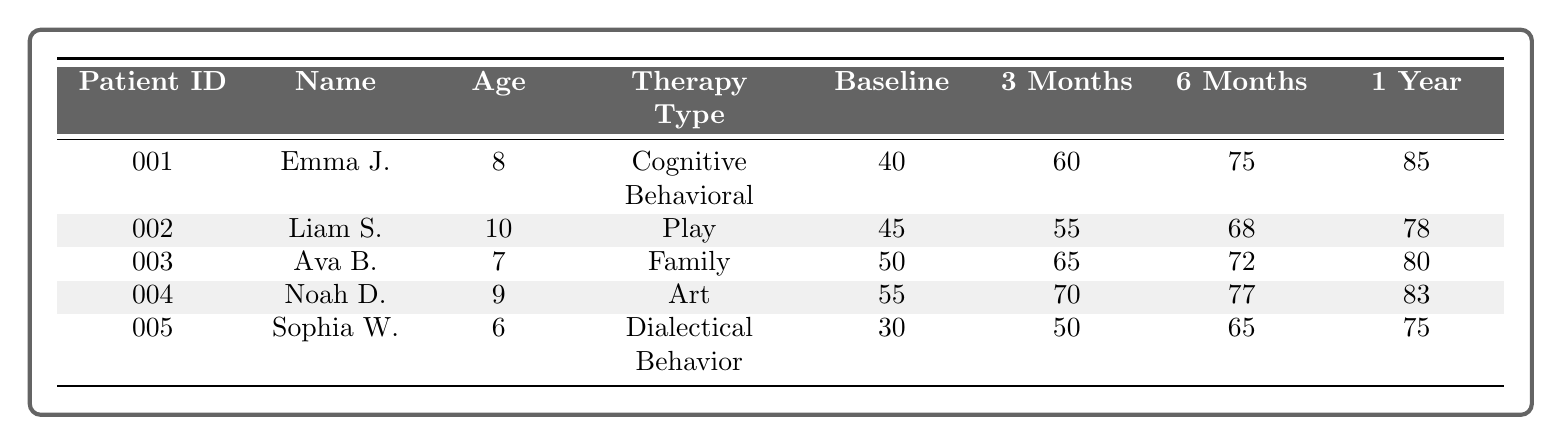What is the baseline emotional well-being score of Emma Johnson? Emma Johnson's row has a baseline emotional well-being score listed in the table. Referring to her entry, the score is 40.
Answer: 40 What therapy type did Liam Smith undergo? In the table, Liam Smith's therapy type is specified in his row. He underwent Play Therapy.
Answer: Play Therapy What was the emotional well-being score of Sophia Wilson after 6 months? In Sophia Wilson's row, the score after 6 months is provided. This score is 65.
Answer: 65 Which patient had the highest score after one year? To find this, we compare the one-year scores of all patients. The scores are 85 (Emma), 78 (Liam), 80 (Ava), 83 (Noah), and 75 (Sophia). Emma Johnson has the highest score at 85.
Answer: Emma Johnson What is the average emotional well-being score after 1 year for all patients? The one-year scores for all patients are 85, 78, 80, 83, and 75. Adding them gives 401. There are 5 patients, so 401/5 = 80.2. The average score is approximately 80.
Answer: 80.2 Did Noah Davis show improvement in his emotional well-being score over the therapy duration? We need to check the scores at different times. His baseline score is 55, 3 months is 70, 6 months is 77, and after one year it's 83. Since all subsequent scores are higher than the baseline, he showed improvement.
Answer: Yes Which therapy type had the lowest baseline score, and what was that score? Looking through the baseline emotional well-being scores, Sophia Wilson has the lowest at 30, and she underwent Dialectical Behavior Therapy.
Answer: Dialectical Behavior Therapy, 30 What is the difference in the emotional well-being score of Ava Brown from baseline to the score after 6 months? Ava Brown's baseline score is 50 and her 6-month score is 72. The difference is 72 - 50 = 22.
Answer: 22 How much did Liam Smith's emotional well-being score increase after 1 year compared to his baseline? Liam's baseline score is 45, and his score after 1 year is 78. The increase is 78 - 45 = 33.
Answer: 33 Which two patients had a final score above 80 after one year? Checking the one-year scores, Emma Johnson (85) and Ava Brown (80) are the only patients above 80.
Answer: Emma Johnson and Ava Brown Compared to the scores after 3 months, who had the largest improvement by 1 year? We will review each patient's 3-month and 1-year scores: Emma (60 to 85 = 25), Liam (55 to 78 = 23), Ava (65 to 80 = 15), Noah (70 to 83 = 13), Sophia (50 to 75 = 25). Emma and Sophia share the largest improvement of 25.
Answer: Emma Johnson and Sophia Wilson 